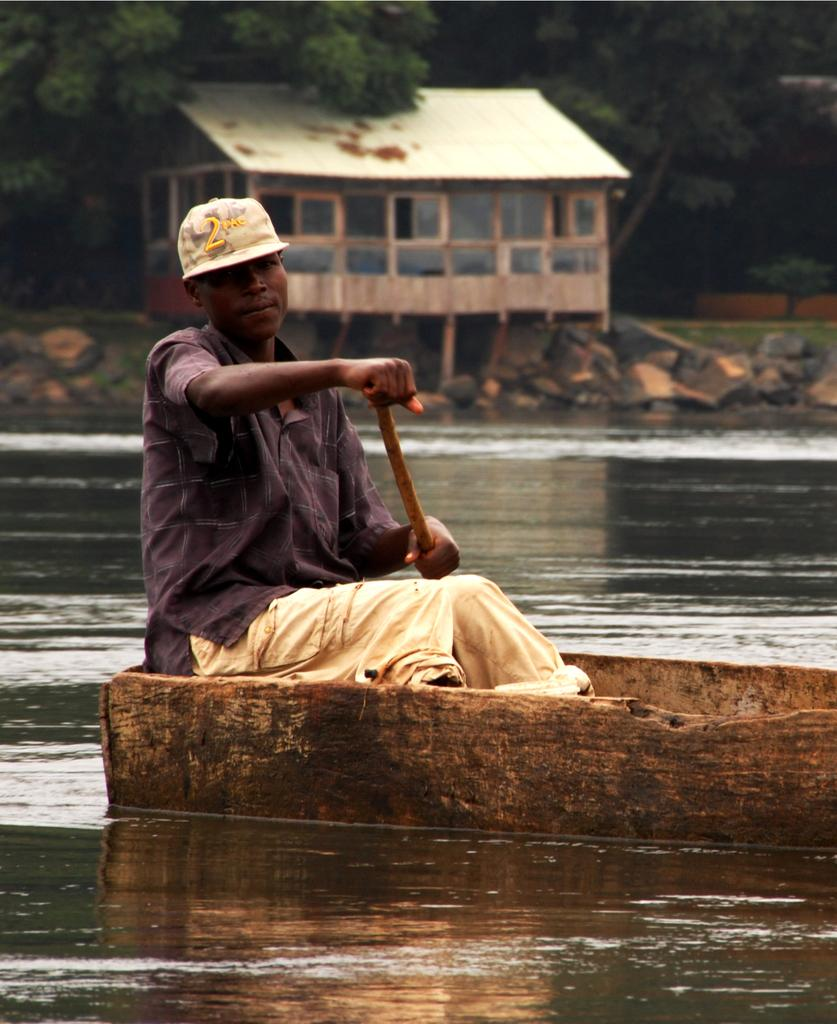What is present in the image that is related to water? There is water in the image. Can you describe the man in the image? The man in the image is wearing a hat and a violet-colored dress. What can be seen in the background of the image? There is a house, trees, and rocks in the background of the image. What language is the man speaking in the image? The image does not provide any information about the language being spoken by the man. Can you tell me how many rings the man is wearing in the image? There is no mention of rings in the image; the man is wearing a hat and a violet-colored dress. 